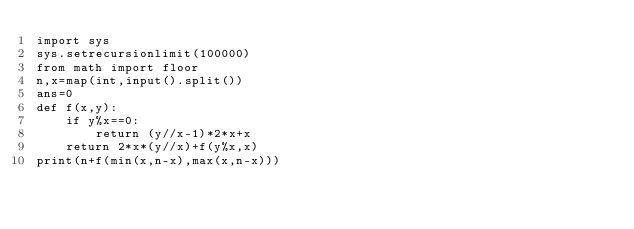<code> <loc_0><loc_0><loc_500><loc_500><_Python_>import sys
sys.setrecursionlimit(100000)
from math import floor
n,x=map(int,input().split())
ans=0
def f(x,y):
    if y%x==0:
        return (y//x-1)*2*x+x
    return 2*x*(y//x)+f(y%x,x)
print(n+f(min(x,n-x),max(x,n-x)))</code> 